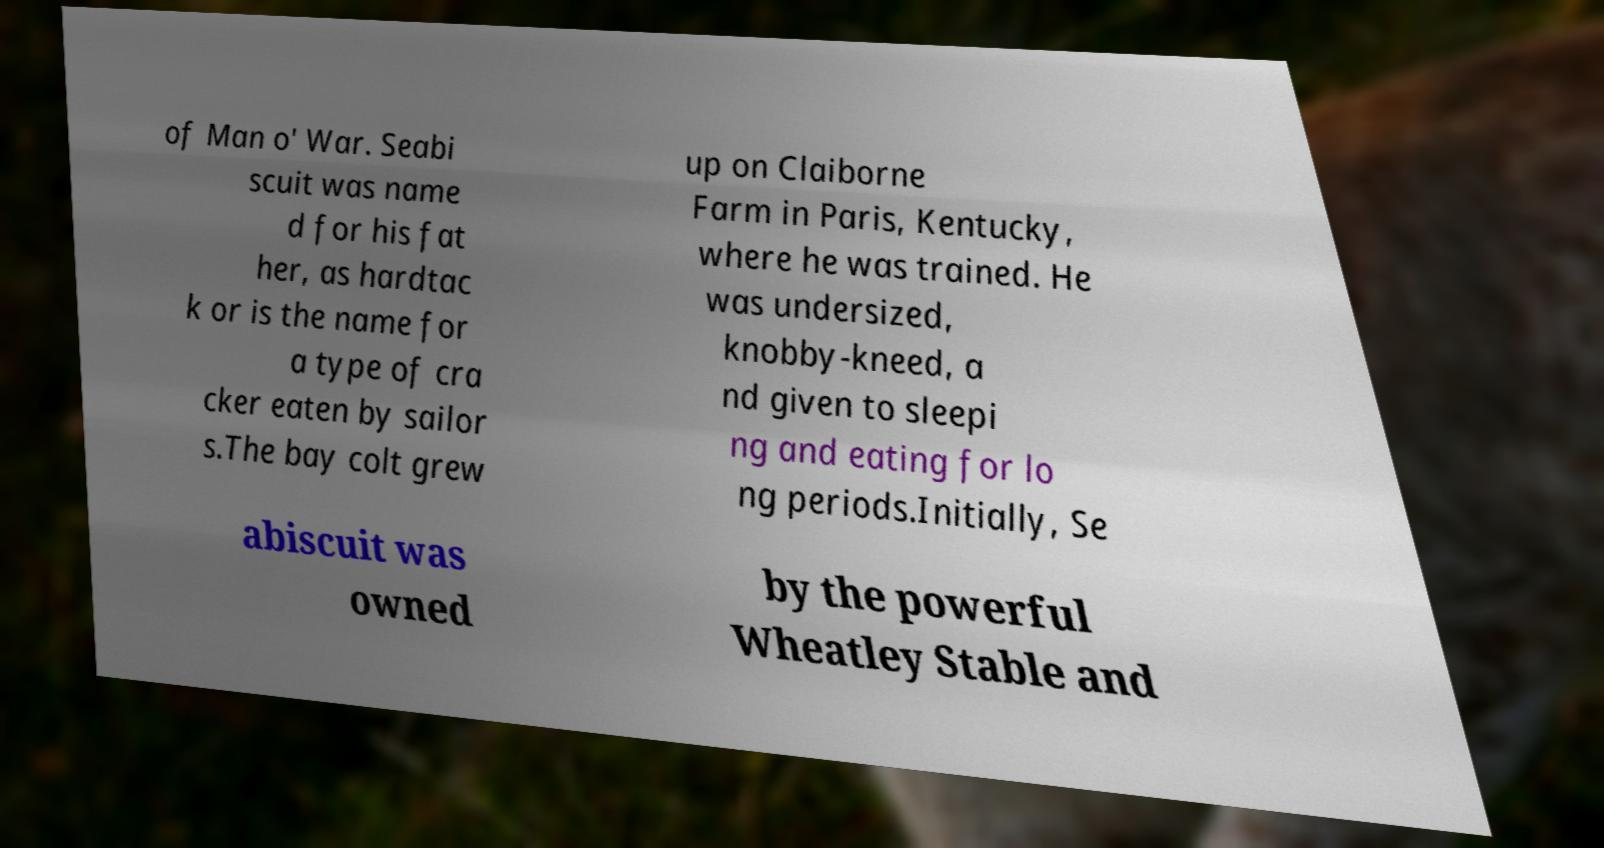Can you read and provide the text displayed in the image?This photo seems to have some interesting text. Can you extract and type it out for me? of Man o' War. Seabi scuit was name d for his fat her, as hardtac k or is the name for a type of cra cker eaten by sailor s.The bay colt grew up on Claiborne Farm in Paris, Kentucky, where he was trained. He was undersized, knobby-kneed, a nd given to sleepi ng and eating for lo ng periods.Initially, Se abiscuit was owned by the powerful Wheatley Stable and 